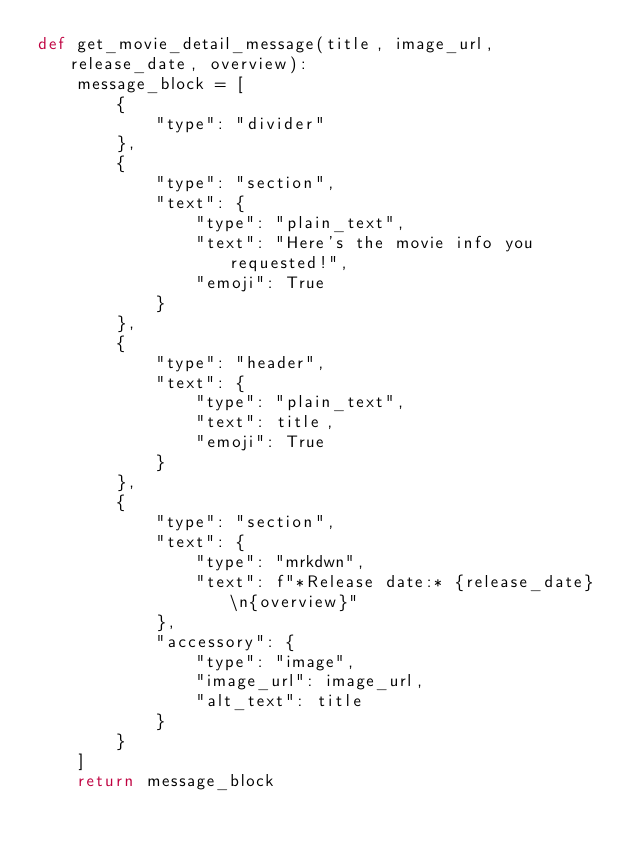<code> <loc_0><loc_0><loc_500><loc_500><_Python_>def get_movie_detail_message(title, image_url, release_date, overview):
    message_block = [
        {
            "type": "divider"
        },
        {
            "type": "section",
            "text": {
                "type": "plain_text",
                "text": "Here's the movie info you requested!",
                "emoji": True
            }
        },
        {
            "type": "header",
            "text": {
                "type": "plain_text",
                "text": title,
                "emoji": True
            }
        },
        {
            "type": "section",
            "text": {
                "type": "mrkdwn",
                "text": f"*Release date:* {release_date} \n{overview}"
            },
            "accessory": {
                "type": "image",
                "image_url": image_url,
                "alt_text": title
            }
        }
    ]
    return message_block
</code> 